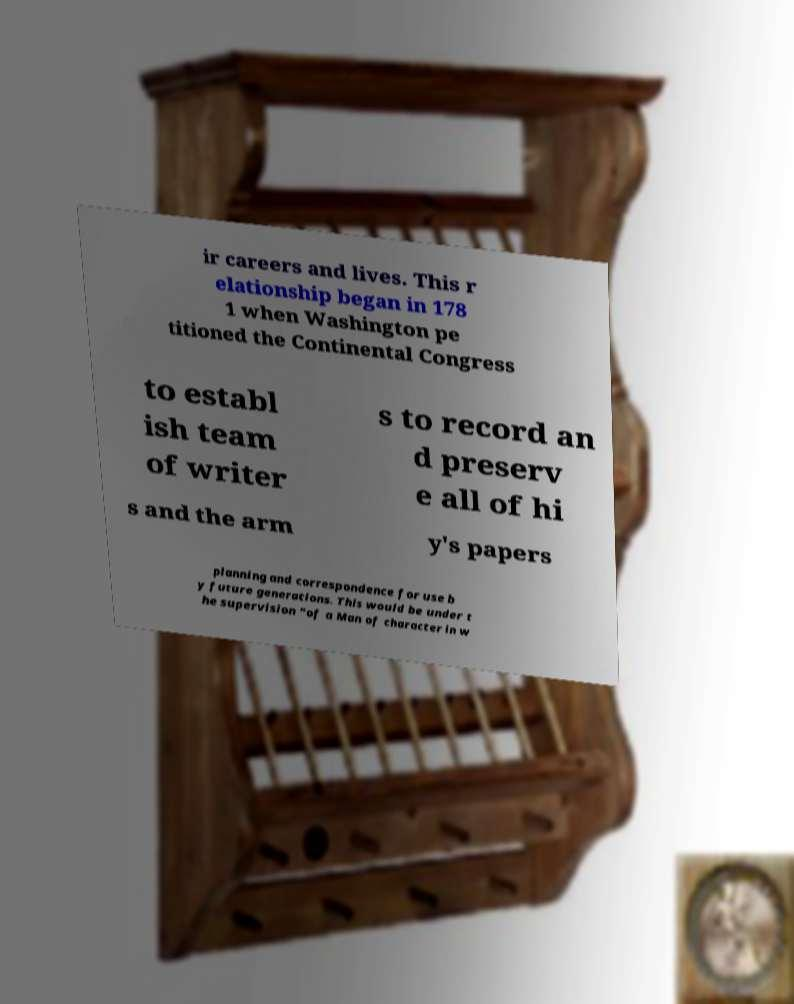Can you accurately transcribe the text from the provided image for me? ir careers and lives. This r elationship began in 178 1 when Washington pe titioned the Continental Congress to establ ish team of writer s to record an d preserv e all of hi s and the arm y's papers planning and correspondence for use b y future generations. This would be under t he supervision “of a Man of character in w 